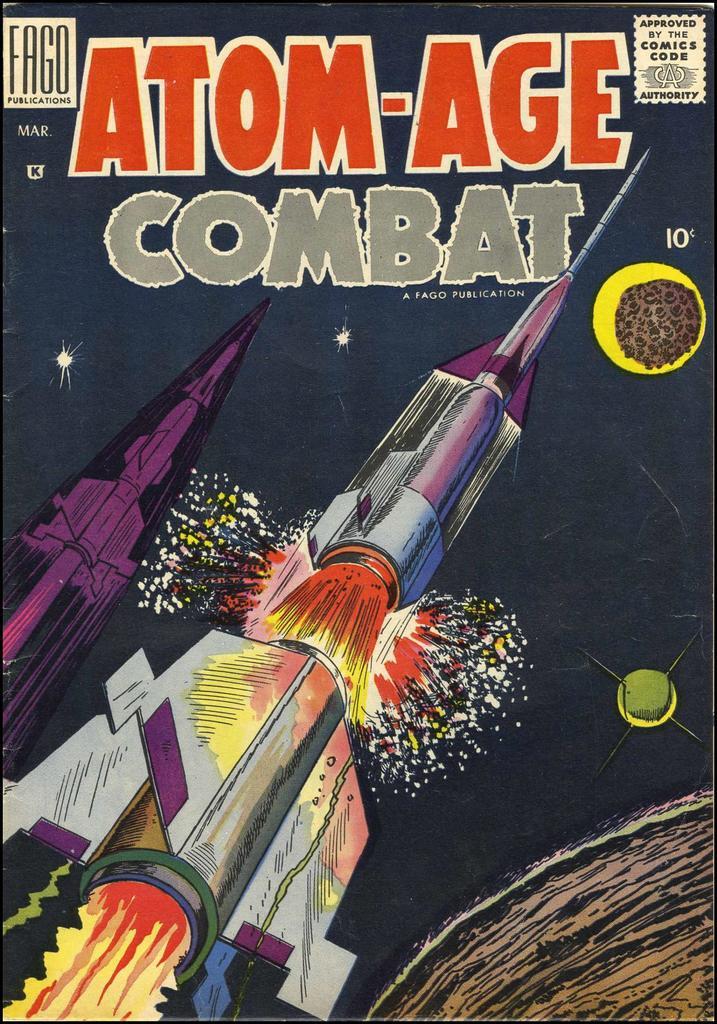What is the title of the publication?
Your answer should be very brief. Atom-age combat. 